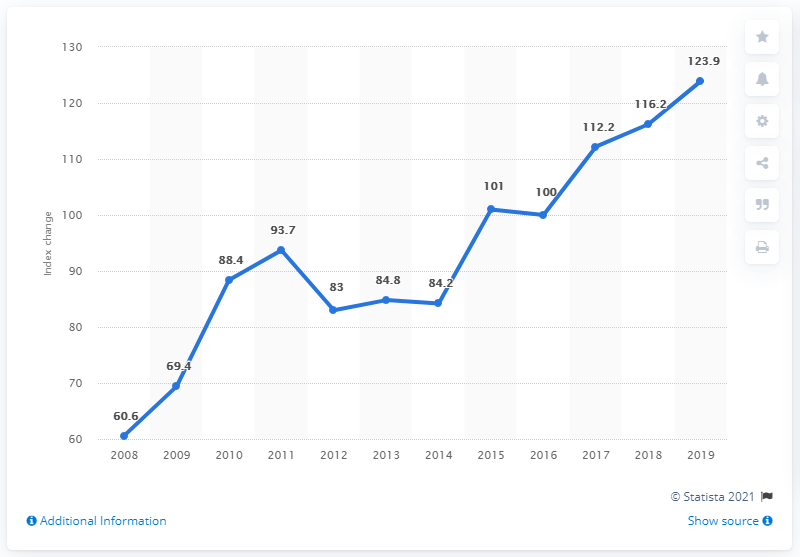Mention a couple of crucial points in this snapshot. In 2019, the construction output index for infrastructure in Great Britain was 123.9. 